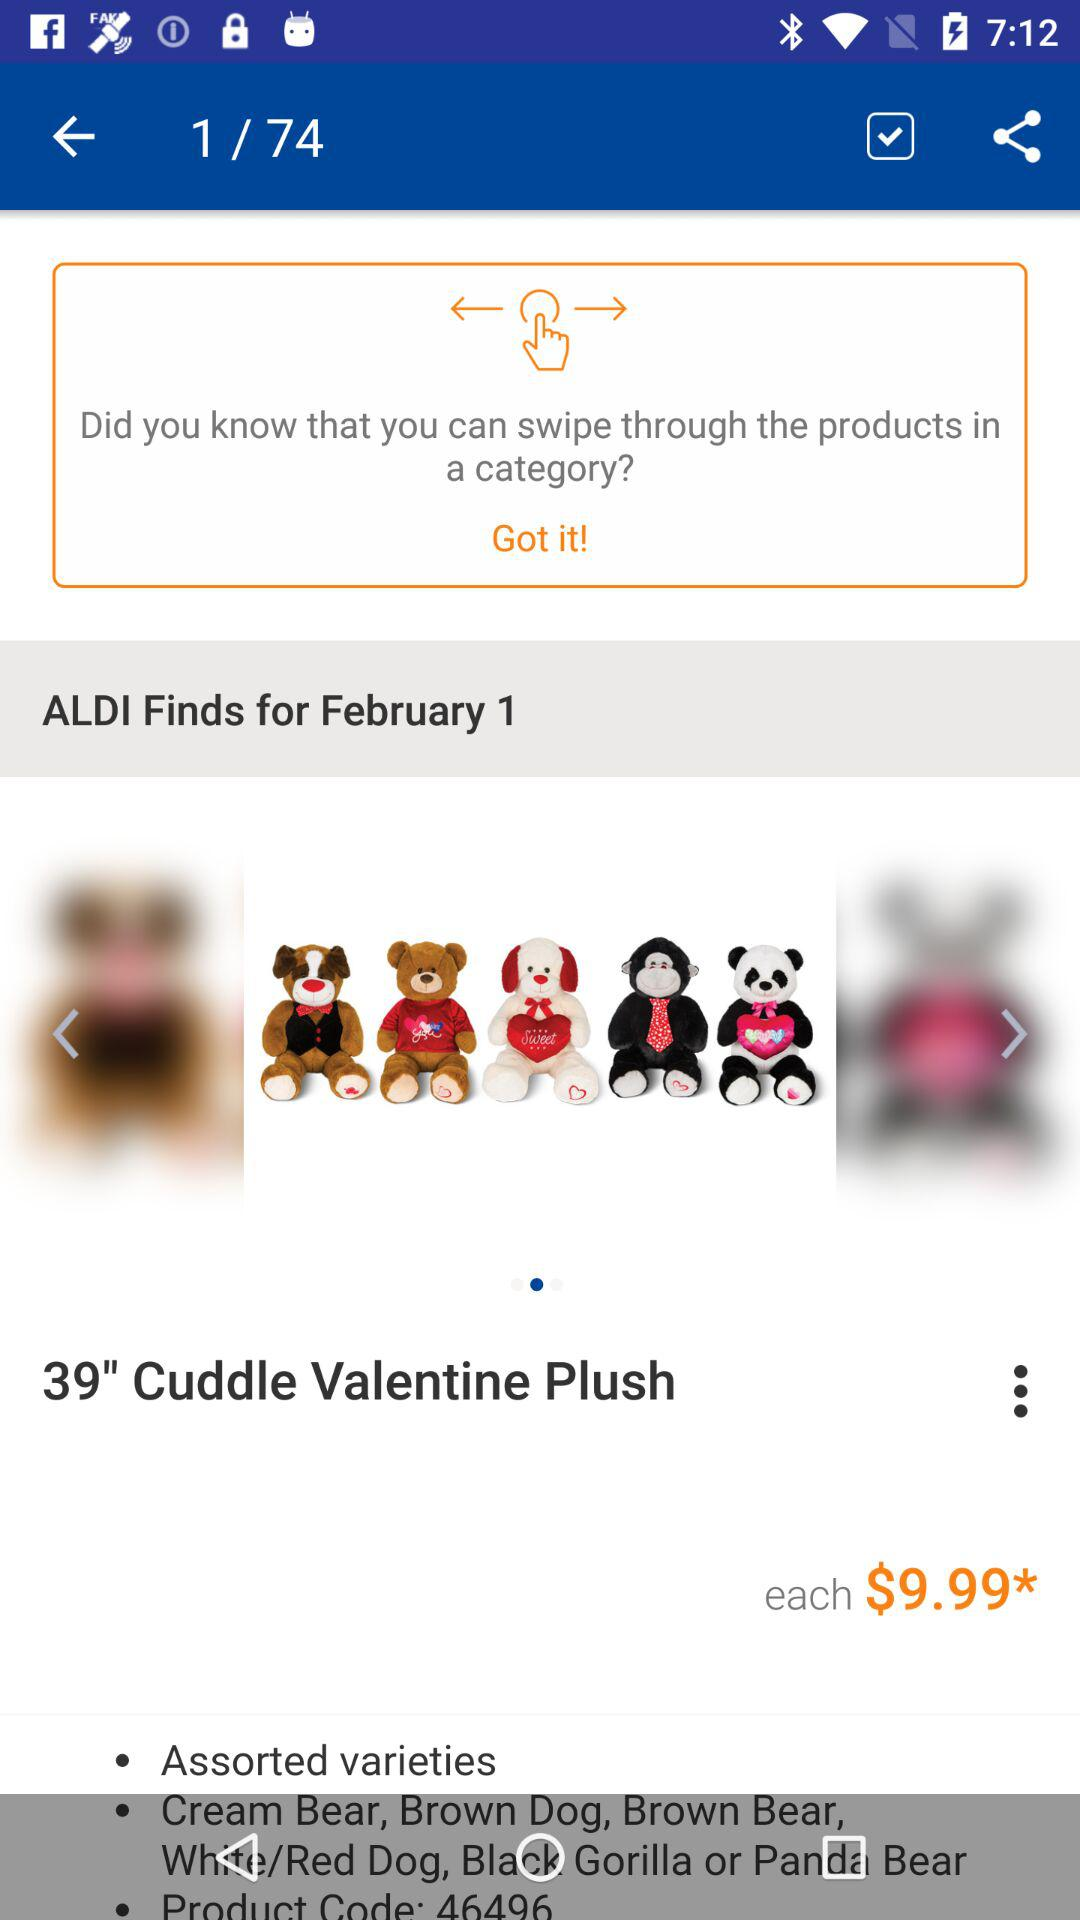How many different types of teddy bears are available?
Answer the question using a single word or phrase. 5 